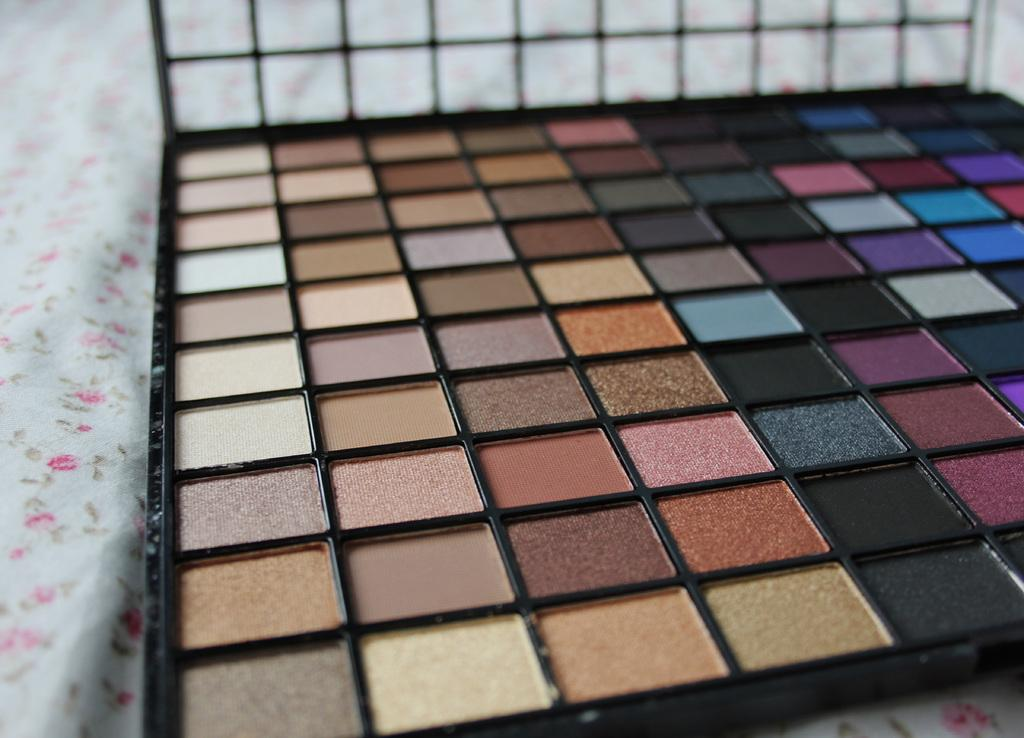What type of items are present in the image? There are cosmetic colors in the image. Where are the cosmetic colors stored? The cosmetic colors are present in a makeup box. Where is the makeup box located? The makeup box is on a bed. What type of cars can be seen in the image? There are no cars present in the image; it features cosmetic colors in a makeup box on a bed. 